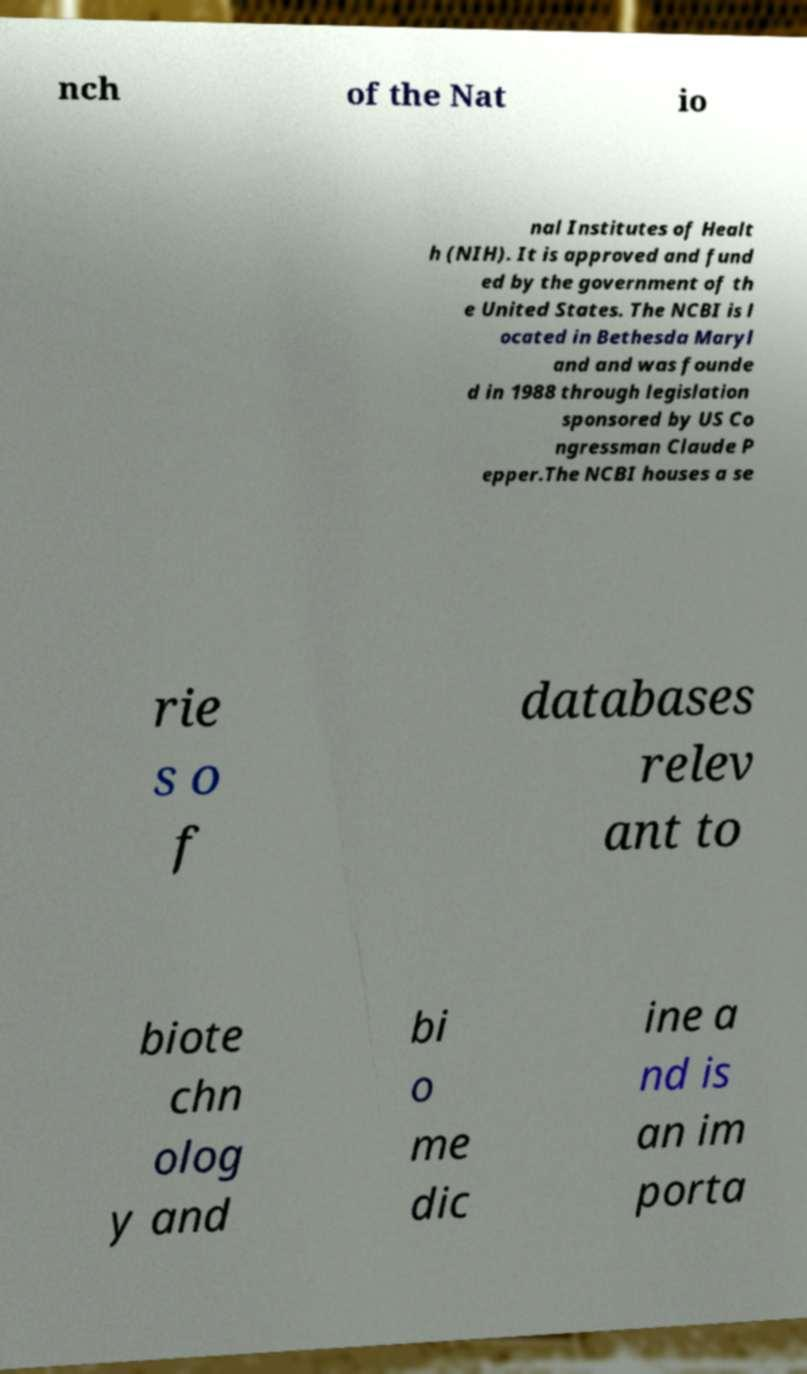What messages or text are displayed in this image? I need them in a readable, typed format. nch of the Nat io nal Institutes of Healt h (NIH). It is approved and fund ed by the government of th e United States. The NCBI is l ocated in Bethesda Maryl and and was founde d in 1988 through legislation sponsored by US Co ngressman Claude P epper.The NCBI houses a se rie s o f databases relev ant to biote chn olog y and bi o me dic ine a nd is an im porta 